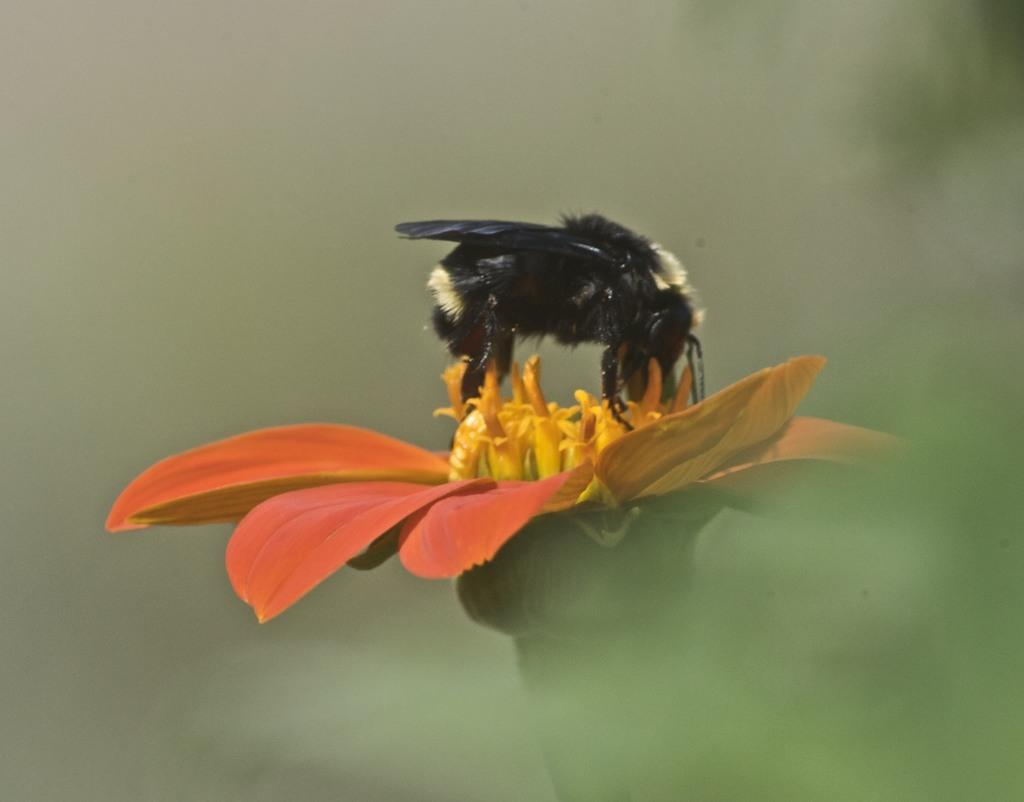What is the main subject of the image? The main subject of the image is a flower. Can you describe the colors of the flower? The flower has red and yellow colors. Is there anything else present on the flower in the image? Yes, there is an insect on the flower. What are the colors of the insect? The insect has black and white colors. How would you describe the background of the image? The background of the image is blurred. What type of slope can be seen in the image? There is no slope present in the image; it features a flower with an insect on it and a blurred background. 